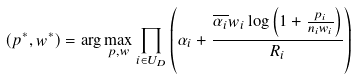Convert formula to latex. <formula><loc_0><loc_0><loc_500><loc_500>( p ^ { * } , w ^ { * } ) = \arg \max _ { p , w } \prod _ { i \in U _ { D } } { \left ( \alpha _ { i } + \frac { \overline { \alpha _ { i } } w _ { i } \log \left ( { 1 + \frac { p _ { i } } { n _ { i } w _ { i } } } \right ) } { R _ { i } } \right ) }</formula> 